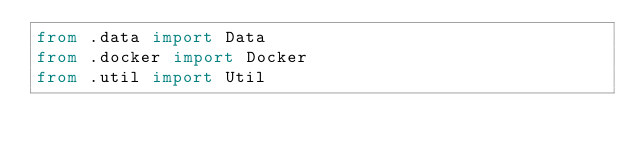<code> <loc_0><loc_0><loc_500><loc_500><_Python_>from .data import Data
from .docker import Docker
from .util import Util
</code> 